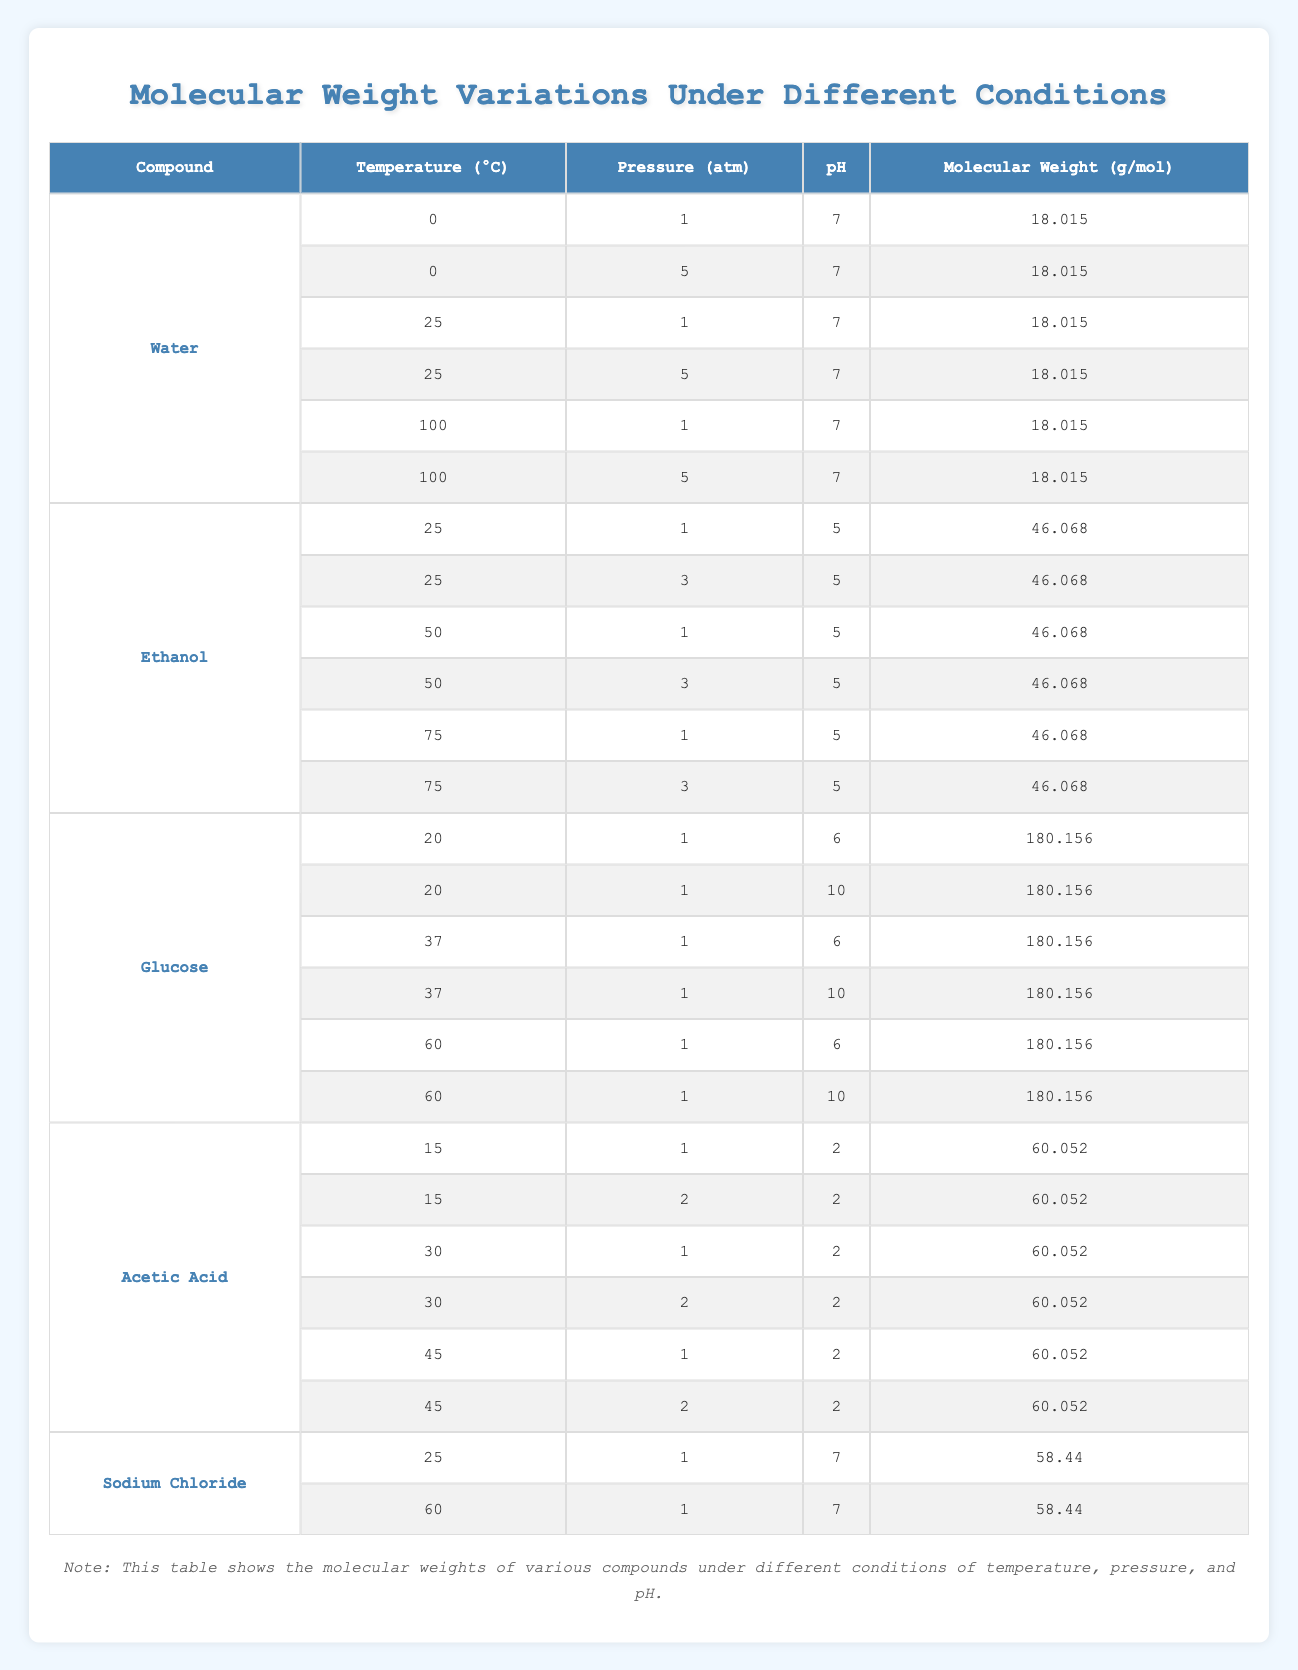What is the molecular weight of water at 100°C and 1 atm? Referring to the table, the row with water at a temperature of 100°C and a pressure of 1 atm shows the molecular weight as 18.015 g/mol.
Answer: 18.015 g/mol How many different molecular weights are recorded for ethanol at varying temperatures and a pressure of 1 atm? The table shows six entries for ethanol, as it has been measured at three different temperatures (25°C, 50°C, and 75°C) with the pressure fixed at 1 atm, each with pH of 5.
Answer: 3 Is the pH of 5 present for any condition of acetic acid? Checking the table, all conditions listed for acetic acid show pH values of either 2 or 5. However, there are no conditions listed where the pH value is 5 with pressure of 1 or 2 atm.
Answer: No What is the molecular weight of glucose at 37°C and pH 10? The entry for glucose at 37°C with a pH of 10 indicates a molecular weight of 180.156 g/mol, as shown in the appropriate row.
Answer: 180.156 g/mol Calculate the average molecular weight of sodium chloride across its recorded conditions. Sodium chloride has two entries, both with a molecular weight of 58.44 g/mol. So, the average is (58.44 + 58.44) / 2 = 58.44 g/mol, since both values are the same.
Answer: 58.44 g/mol Which compound maintains the same molecular weight regardless of the changes in temperature, pressure, or pH? By reviewing the entries for water, ethanol, glucose, acetic acid, and sodium chloride, it is clear that water has a constant molecular weight of 18.015 g/mol in all recorded conditions.
Answer: Water How does the molecular weight of acetic acid compare to that of ethanol at their minimum temperature conditions? The table shows that acetic acid’s molecular weight at 15°C is 60.052 g/mol, while ethanol's at 25°C is 46.068 g/mol. Therefore, 60.052 g/mol is greater than 46.068 g/mol.
Answer: Greater What patterns can be observed in the molecular weights of compounds as temperature increases for glucose? The molecular weight for glucose remains constant at 180.156 g/mol across three different temperatures (20°C, 37°C, 60°C). No change is noted with temperature variations.
Answer: No change observed Is there any condition under which the molecular weight of ethanol varies? The molecular weight of ethanol remains constant at 46.068 g/mol across all recorded conditions, despite pressure and temperature differences.
Answer: No Which compound has the highest molecular weight at the conditions with the highest temperature recorded? The table indicates that glucose has the highest molecular weight of 180.156 g/mol at 60°C, compared to other compounds listed.
Answer: Glucose Does pressure affect the molecular weight of water? The table shows consistent molecular weights for water at different pressures (1 atm and 5 atm) across all temperatures, proving that pressure does not affect its molecular weight.
Answer: No 